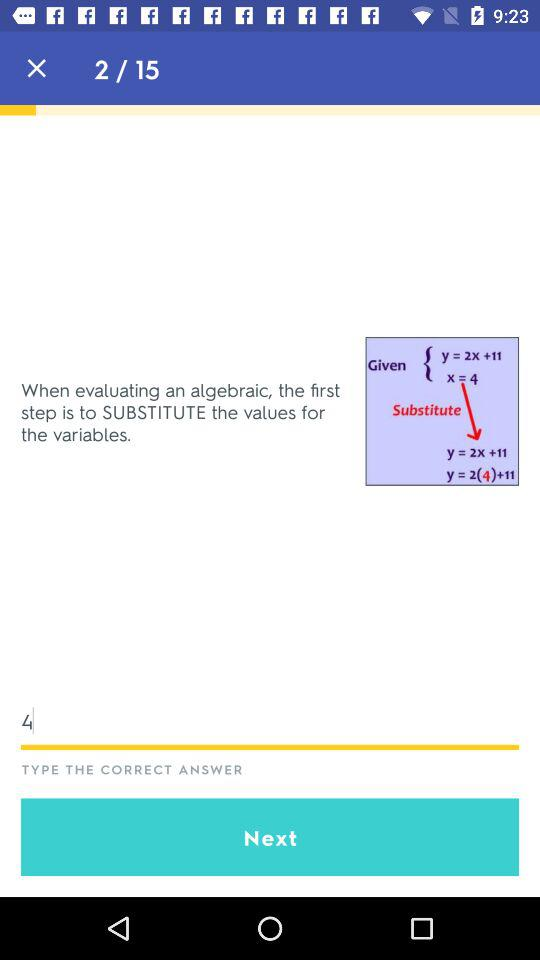What is a typed answer? The answer is "When evaluating an algebraic, the first step is to SUBSTITUTE the values for the variables". 